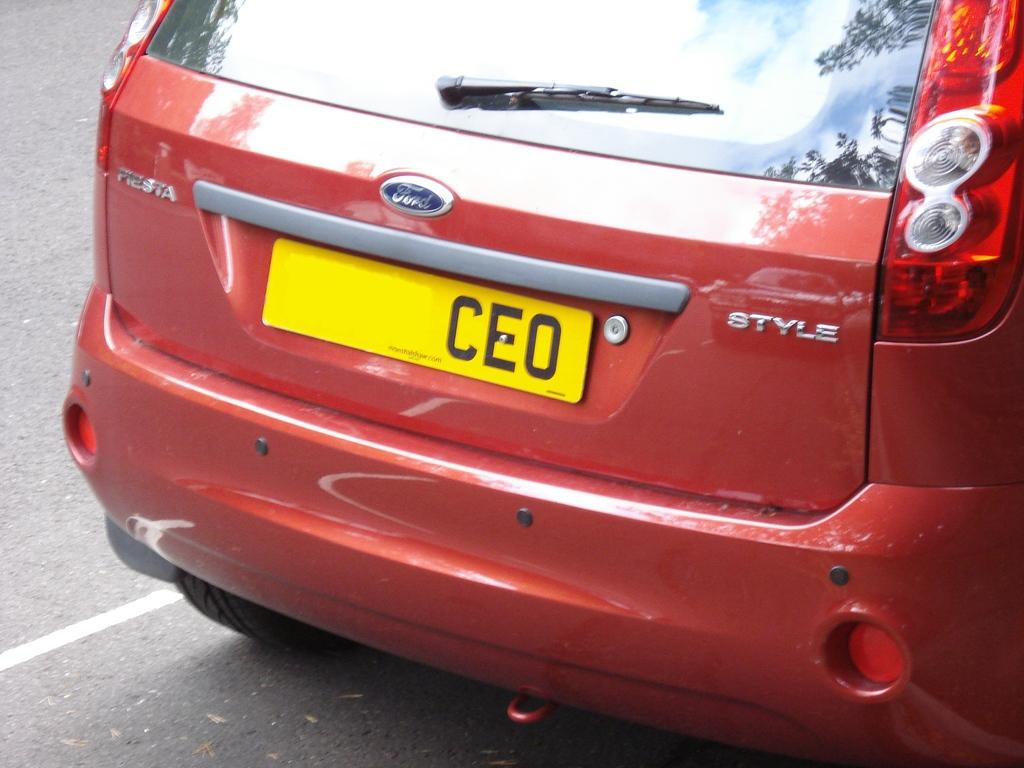Provide a one-sentence caption for the provided image. A red ford Style with the license plate CEO. 